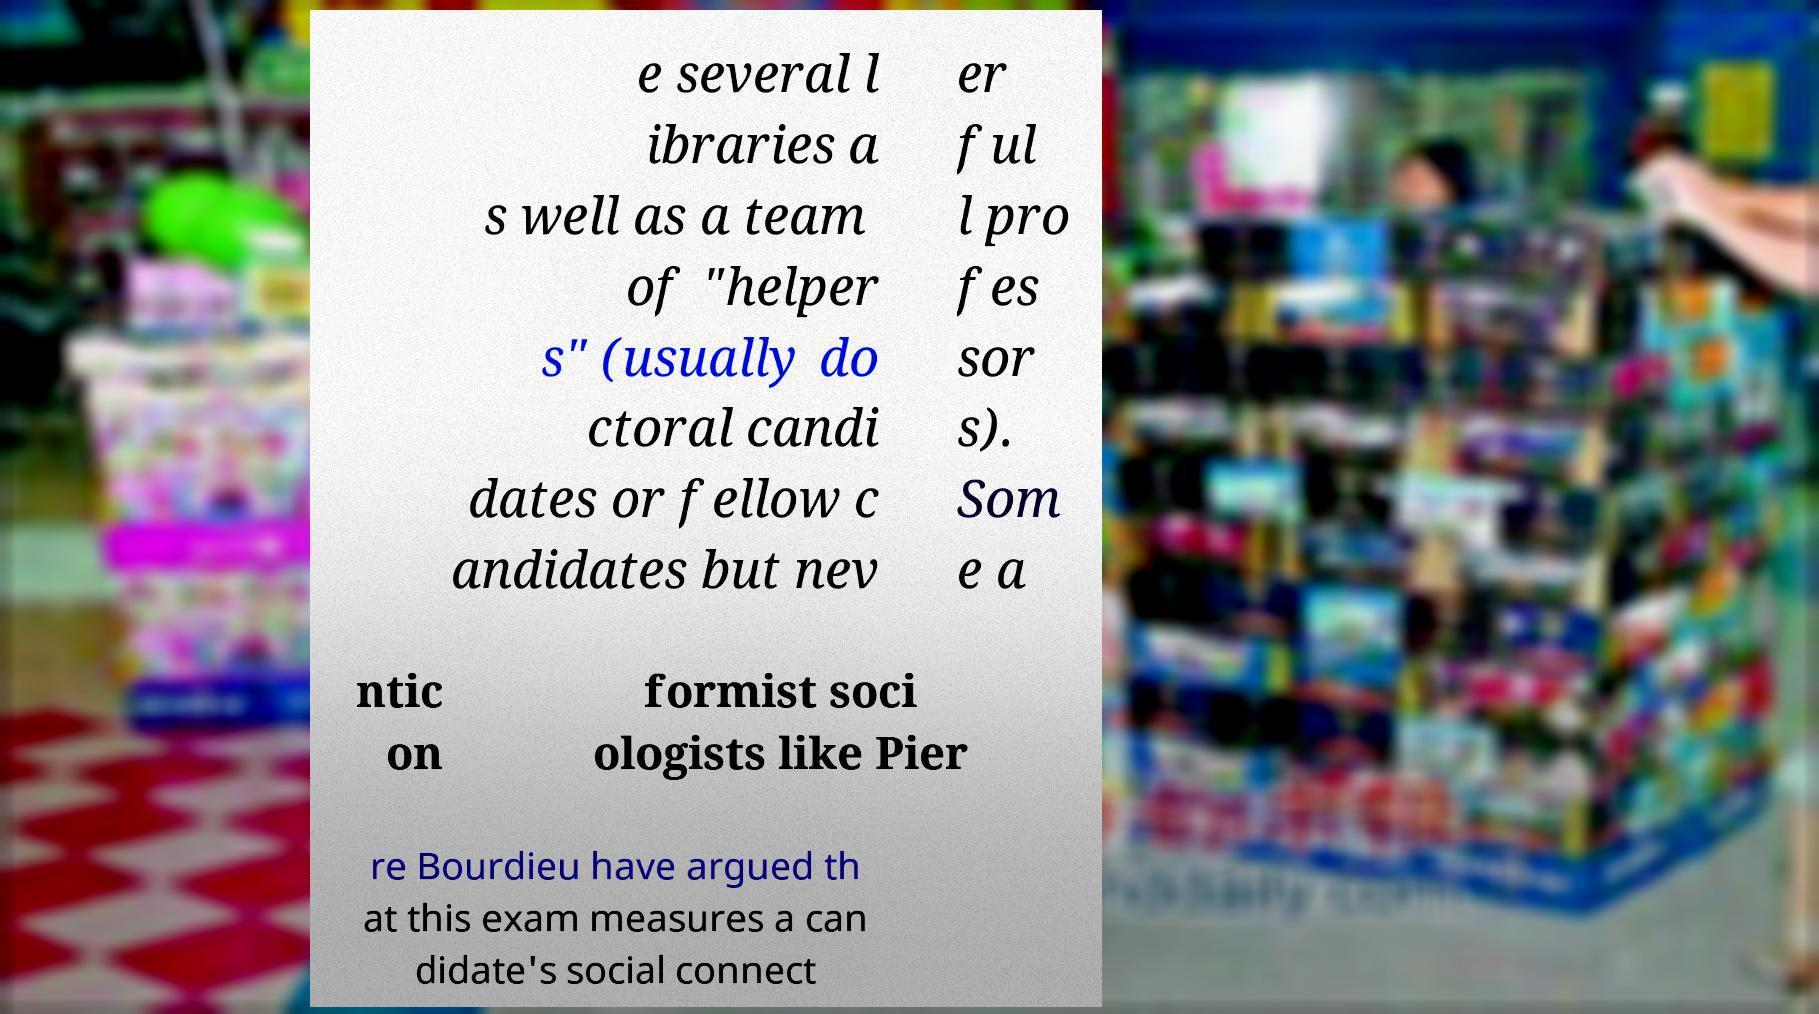Please read and relay the text visible in this image. What does it say? e several l ibraries a s well as a team of "helper s" (usually do ctoral candi dates or fellow c andidates but nev er ful l pro fes sor s). Som e a ntic on formist soci ologists like Pier re Bourdieu have argued th at this exam measures a can didate's social connect 